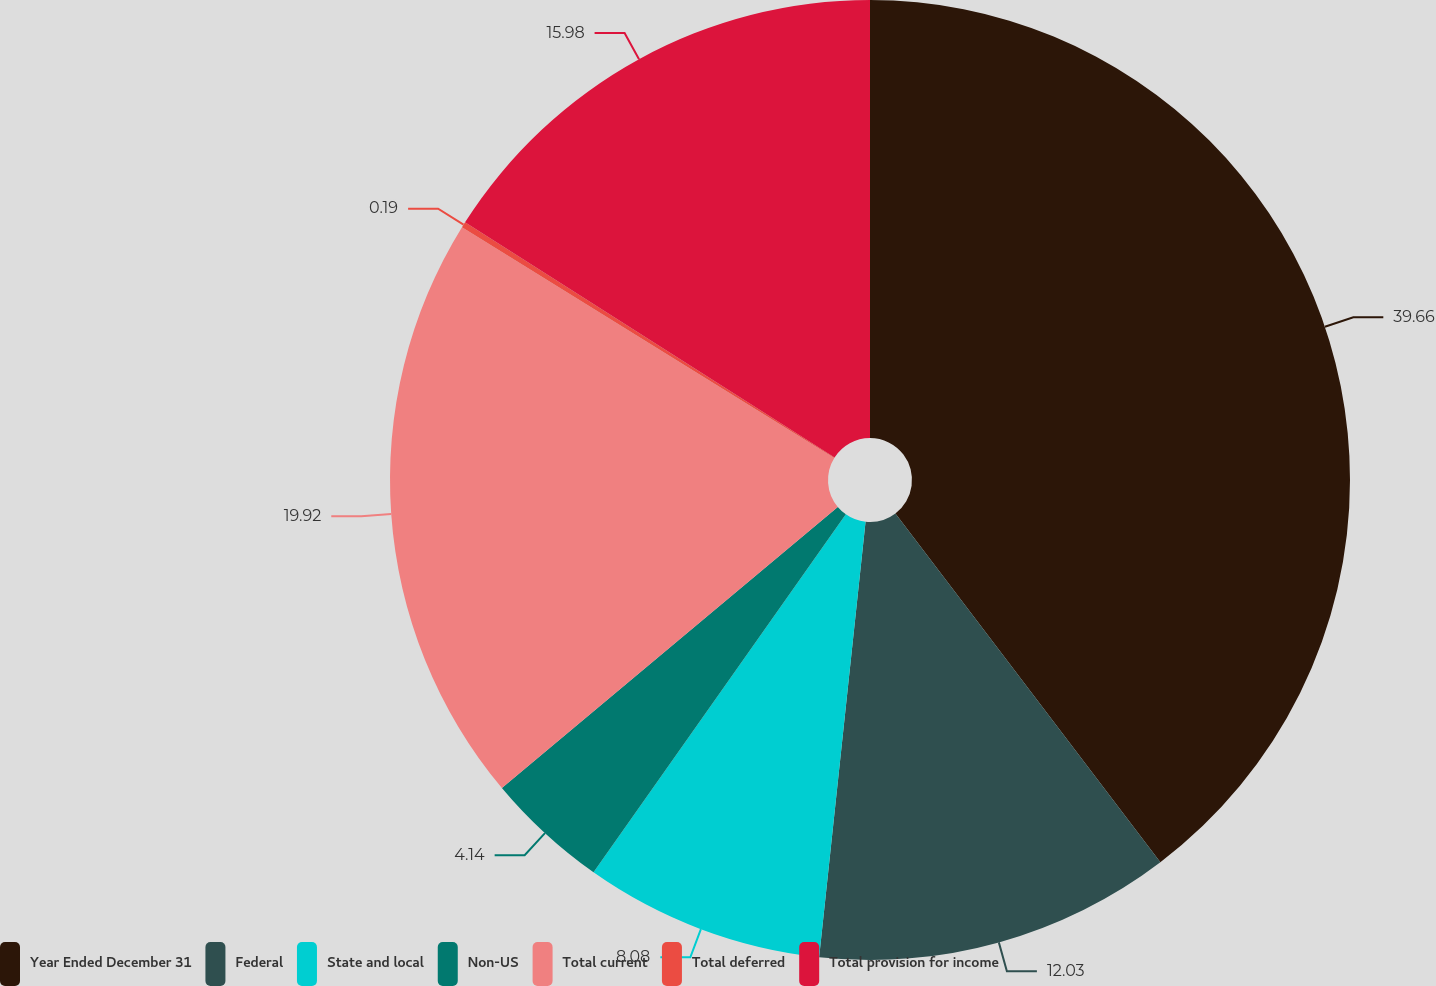Convert chart to OTSL. <chart><loc_0><loc_0><loc_500><loc_500><pie_chart><fcel>Year Ended December 31<fcel>Federal<fcel>State and local<fcel>Non-US<fcel>Total current<fcel>Total deferred<fcel>Total provision for income<nl><fcel>39.66%<fcel>12.03%<fcel>8.08%<fcel>4.14%<fcel>19.92%<fcel>0.19%<fcel>15.98%<nl></chart> 